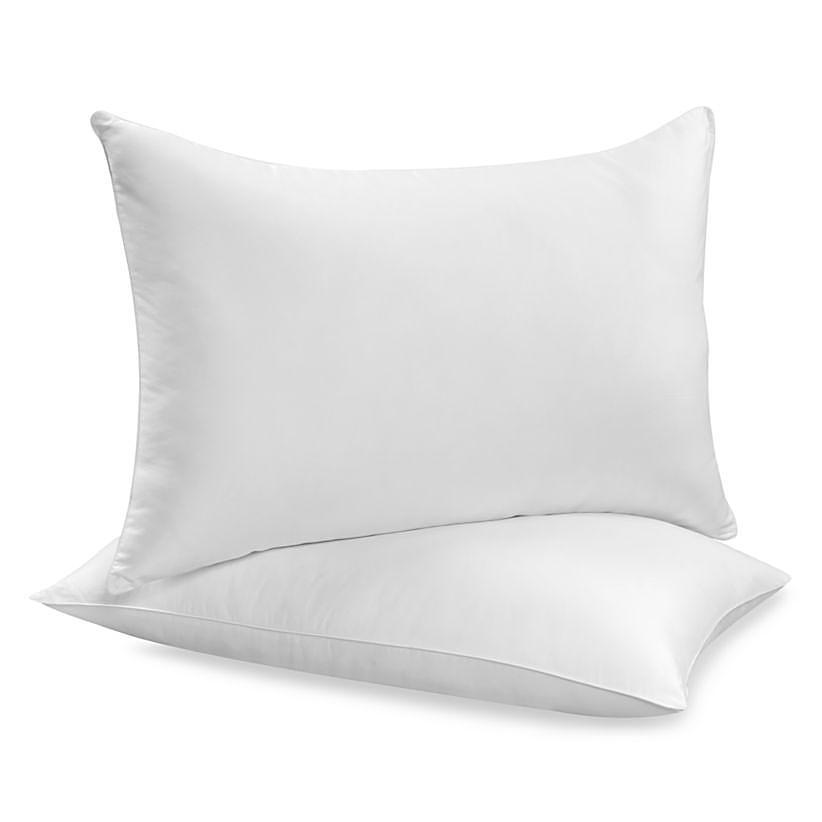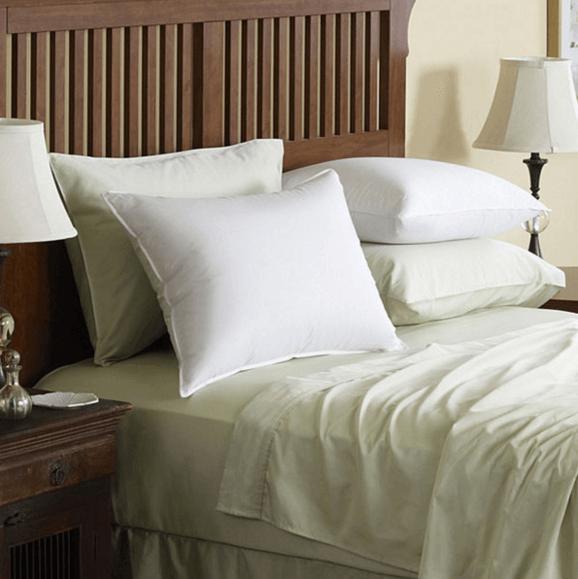The first image is the image on the left, the second image is the image on the right. Assess this claim about the two images: "The right image shows at least four pillows on a bed with a brown headboard and white bedding.". Correct or not? Answer yes or no. Yes. The first image is the image on the left, the second image is the image on the right. Analyze the images presented: Is the assertion "There are fewer than seven pillows visible in total." valid? Answer yes or no. Yes. 